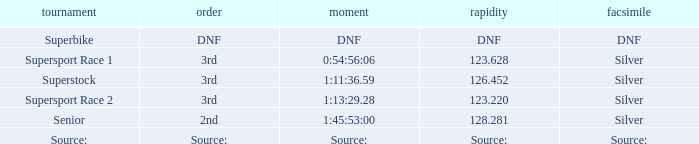Which position has a time of 1:45:53:00? 2nd. 